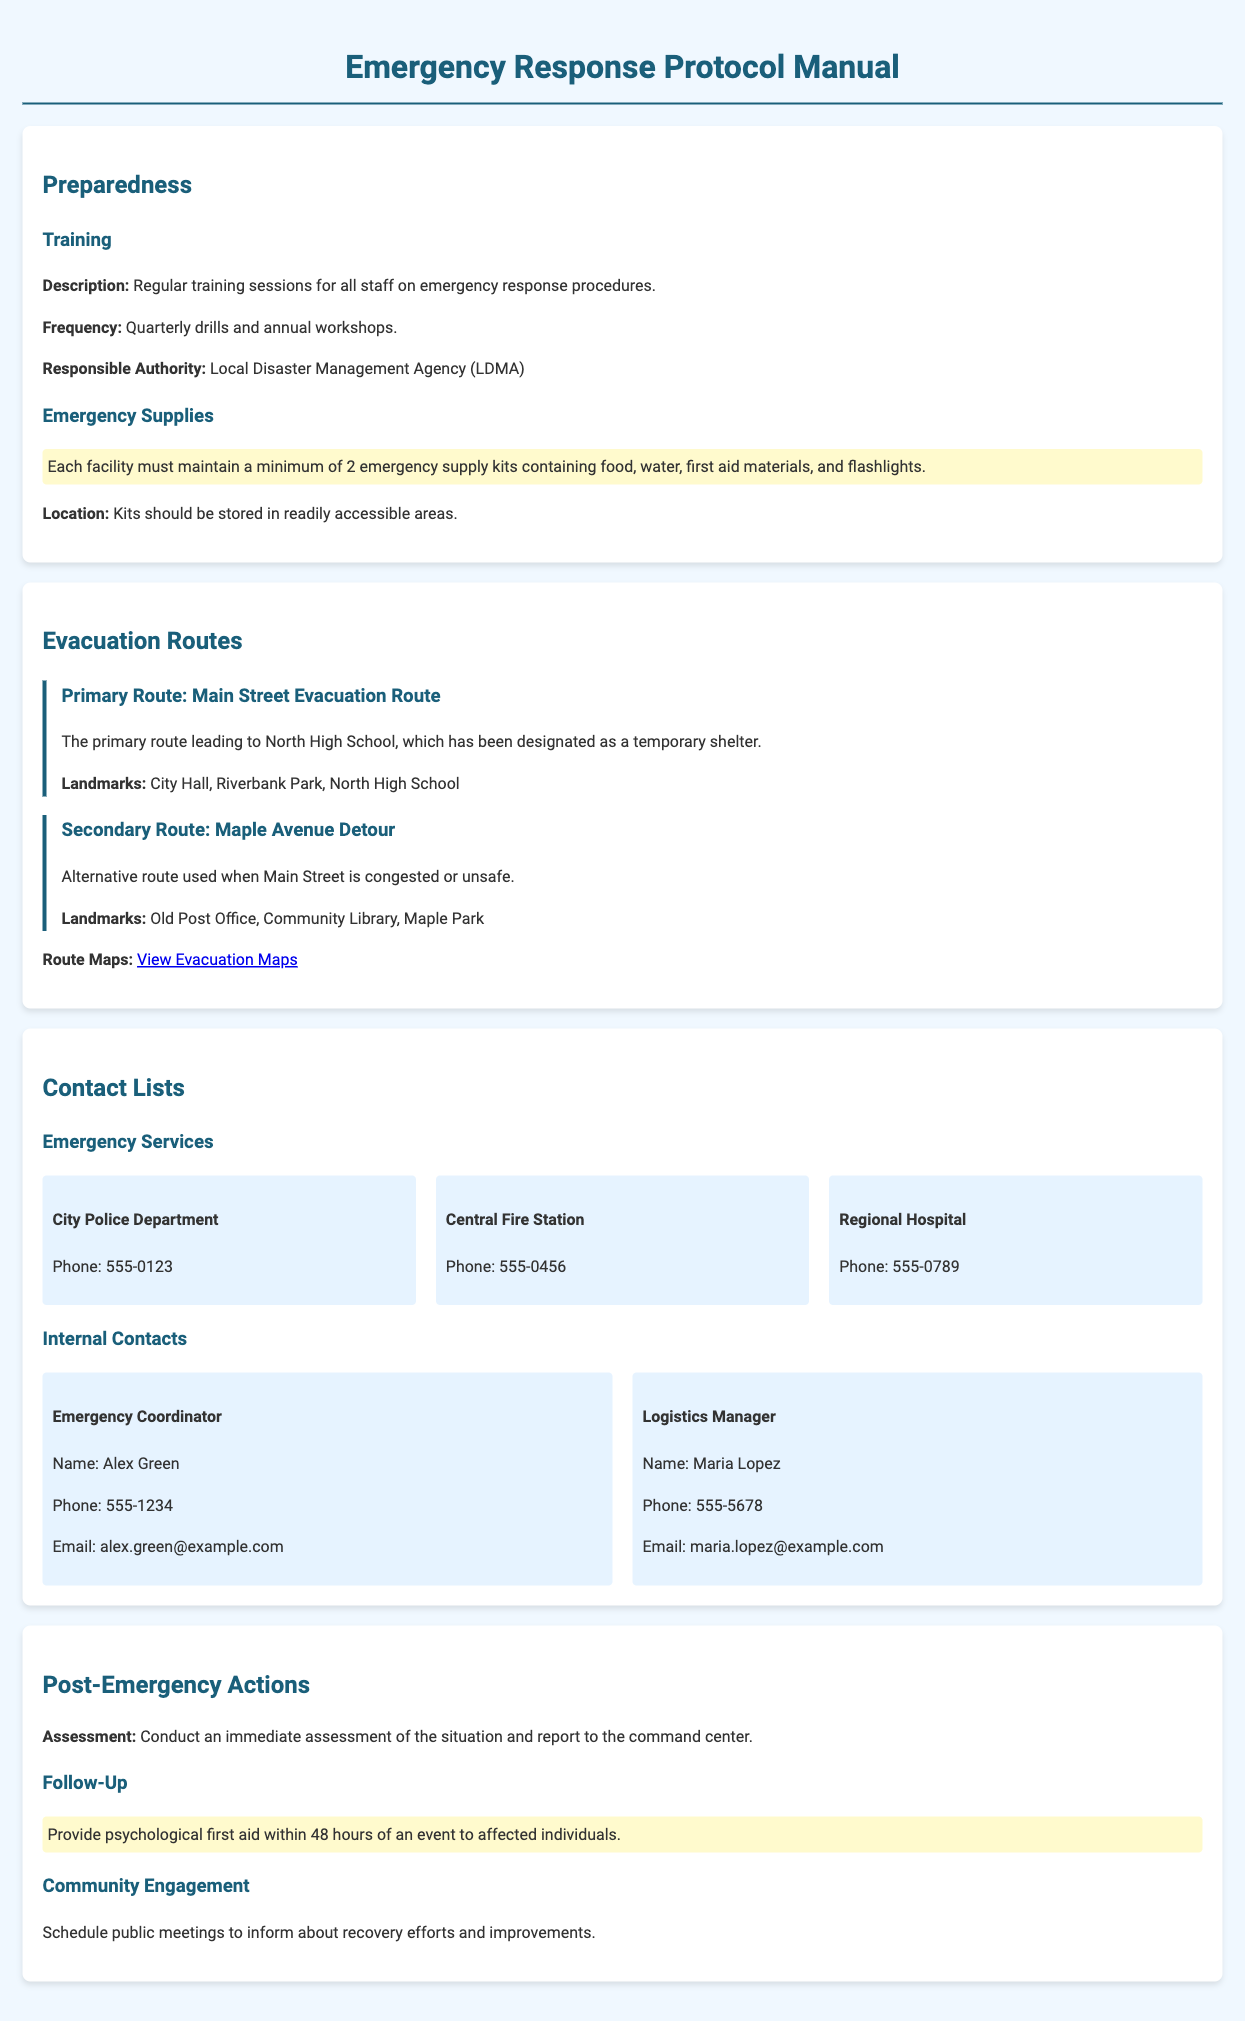what is the responsible authority for training sessions? The responsible authority for training sessions is stated in the document.
Answer: Local Disaster Management Agency (LDMA) how many emergency supply kits must each facility maintain? The document specifies the minimum number of emergency supply kits required for each facility.
Answer: 2 what is the primary evacuation route? The document lists the primary evacuation route leading to a designated temporary shelter.
Answer: Main Street Evacuation Route name one landmark along the secondary route. The question asks for any landmark mentioned along the secondary route in the document.
Answer: Old Post Office who is the Emergency Coordinator? The document provides the name of the person serving as Emergency Coordinator.
Answer: Alex Green what is the frequency of training drills? The document includes information on how often training drills are held.
Answer: Quarterly what should be provided within 48 hours of an event? The document describes post-emergency actions that specify a timeframe for a particular aid.
Answer: Psychological first aid how often are annual workshops held? The document mentions the occurrence of workshops in the emergency response procedures.
Answer: Annually what is the phone number for the Central Fire Station? The document lists contact information for emergency services, including phone numbers.
Answer: 555-0456 